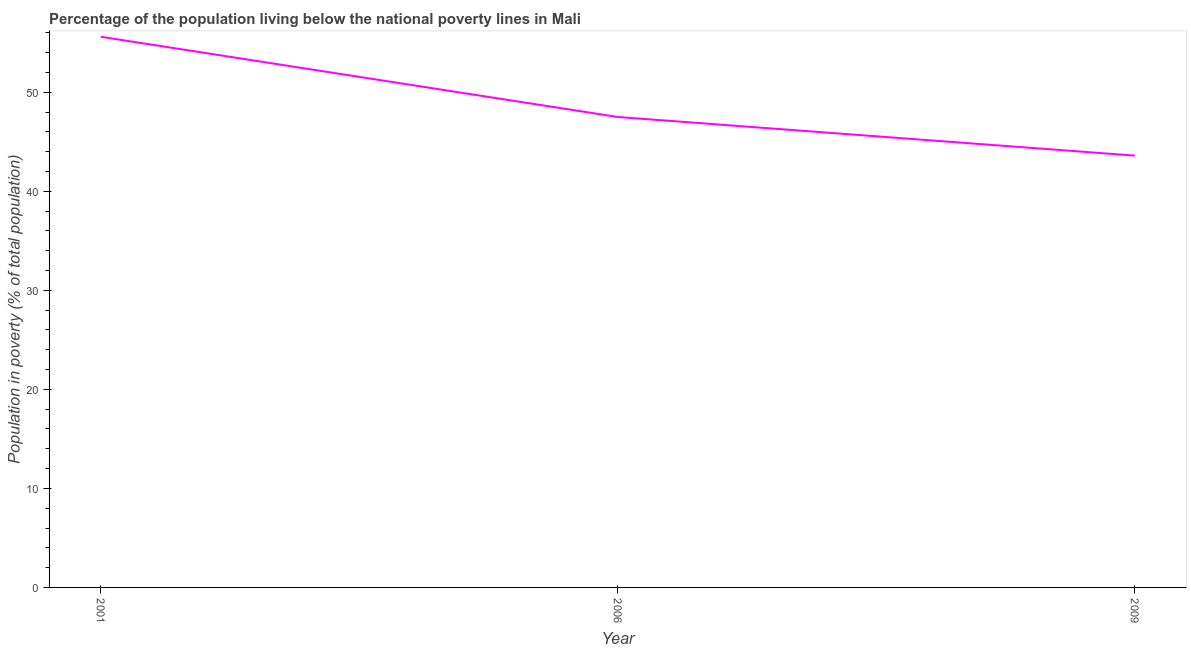What is the percentage of population living below poverty line in 2001?
Offer a terse response. 55.6. Across all years, what is the maximum percentage of population living below poverty line?
Offer a terse response. 55.6. Across all years, what is the minimum percentage of population living below poverty line?
Your response must be concise. 43.6. In which year was the percentage of population living below poverty line maximum?
Give a very brief answer. 2001. What is the sum of the percentage of population living below poverty line?
Give a very brief answer. 146.7. What is the difference between the percentage of population living below poverty line in 2006 and 2009?
Provide a short and direct response. 3.9. What is the average percentage of population living below poverty line per year?
Keep it short and to the point. 48.9. What is the median percentage of population living below poverty line?
Offer a very short reply. 47.5. What is the ratio of the percentage of population living below poverty line in 2006 to that in 2009?
Your answer should be very brief. 1.09. What is the difference between the highest and the second highest percentage of population living below poverty line?
Offer a very short reply. 8.1. Is the sum of the percentage of population living below poverty line in 2006 and 2009 greater than the maximum percentage of population living below poverty line across all years?
Provide a short and direct response. Yes. What is the difference between the highest and the lowest percentage of population living below poverty line?
Offer a terse response. 12. In how many years, is the percentage of population living below poverty line greater than the average percentage of population living below poverty line taken over all years?
Offer a very short reply. 1. Does the percentage of population living below poverty line monotonically increase over the years?
Offer a very short reply. No. How many lines are there?
Provide a succinct answer. 1. What is the difference between two consecutive major ticks on the Y-axis?
Provide a short and direct response. 10. Does the graph contain any zero values?
Offer a very short reply. No. What is the title of the graph?
Your answer should be compact. Percentage of the population living below the national poverty lines in Mali. What is the label or title of the Y-axis?
Your answer should be compact. Population in poverty (% of total population). What is the Population in poverty (% of total population) in 2001?
Your answer should be very brief. 55.6. What is the Population in poverty (% of total population) of 2006?
Your answer should be compact. 47.5. What is the Population in poverty (% of total population) in 2009?
Give a very brief answer. 43.6. What is the difference between the Population in poverty (% of total population) in 2006 and 2009?
Keep it short and to the point. 3.9. What is the ratio of the Population in poverty (% of total population) in 2001 to that in 2006?
Offer a very short reply. 1.17. What is the ratio of the Population in poverty (% of total population) in 2001 to that in 2009?
Your answer should be very brief. 1.27. What is the ratio of the Population in poverty (% of total population) in 2006 to that in 2009?
Ensure brevity in your answer.  1.09. 